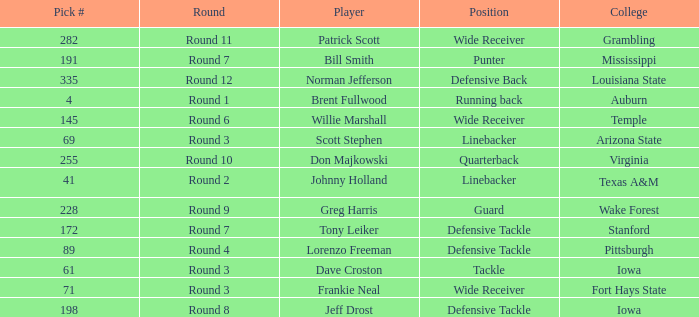Which round goes to Stanford college? Round 7. 